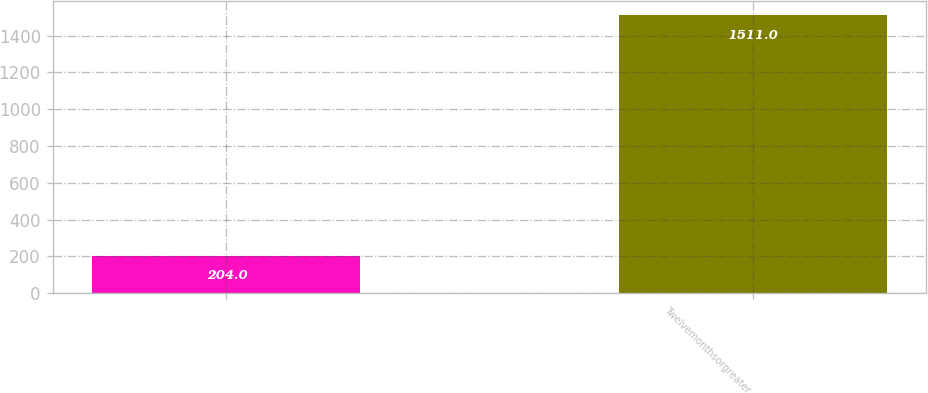Convert chart to OTSL. <chart><loc_0><loc_0><loc_500><loc_500><bar_chart><ecel><fcel>Twelvemonthsorgreater<nl><fcel>204<fcel>1511<nl></chart> 